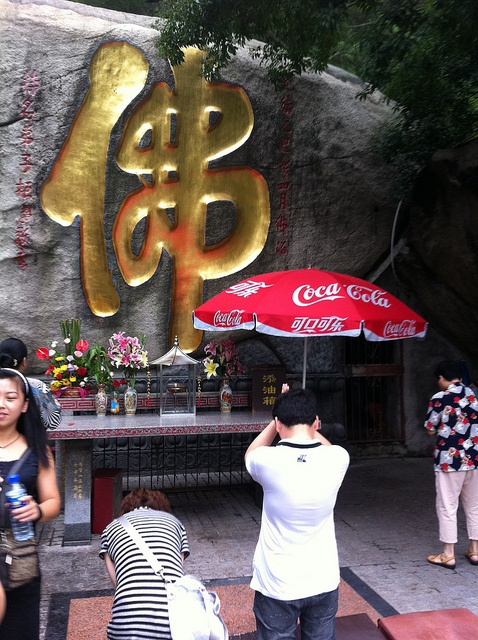Describe the objects in this image and their specific colors. I can see people in ivory, white, black, navy, and purple tones, umbrella in ivory, red, brown, and lavender tones, people in ivory, black, gray, and lightpink tones, people in ivory, white, black, darkgray, and gray tones, and people in ivory, black, lavender, darkgray, and pink tones in this image. 